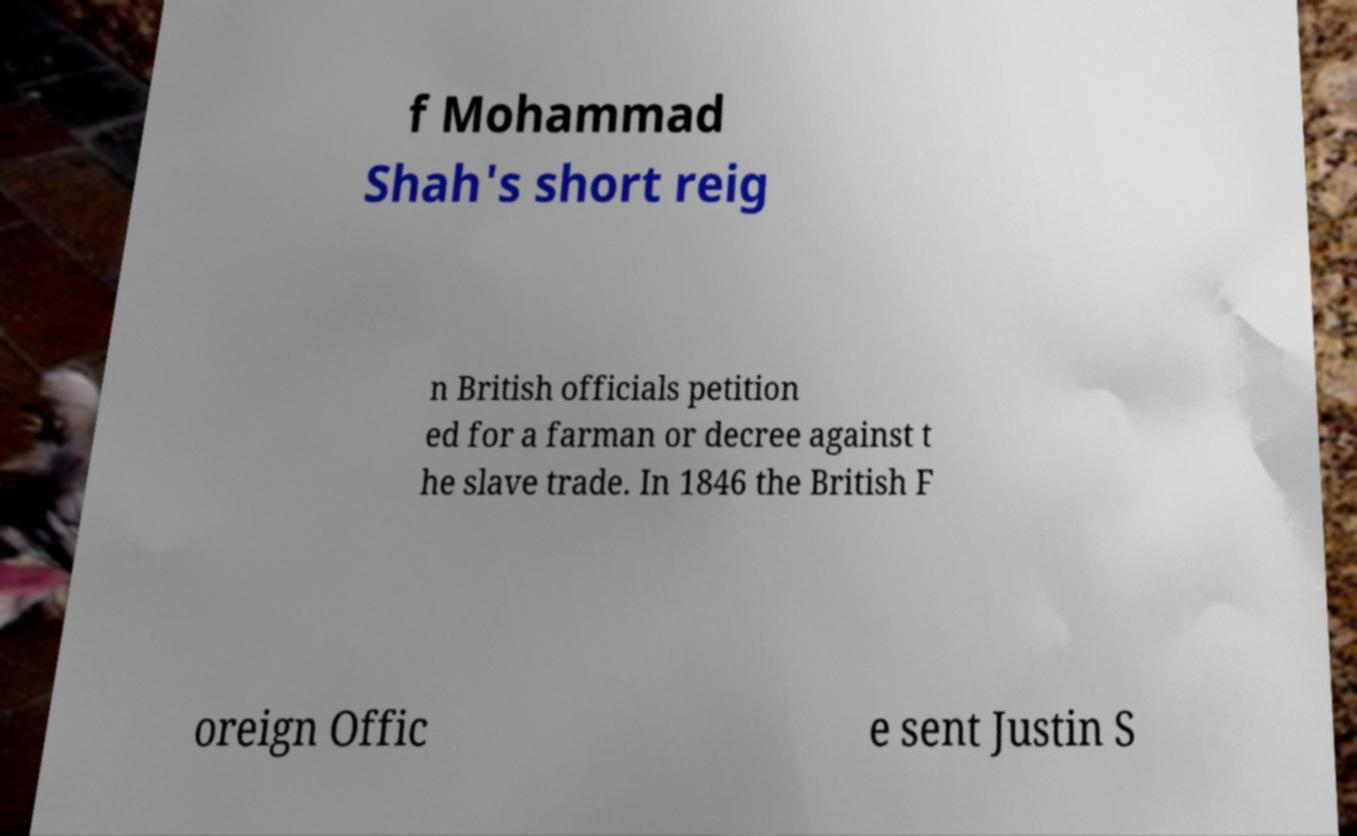Please read and relay the text visible in this image. What does it say? f Mohammad Shah's short reig n British officials petition ed for a farman or decree against t he slave trade. In 1846 the British F oreign Offic e sent Justin S 